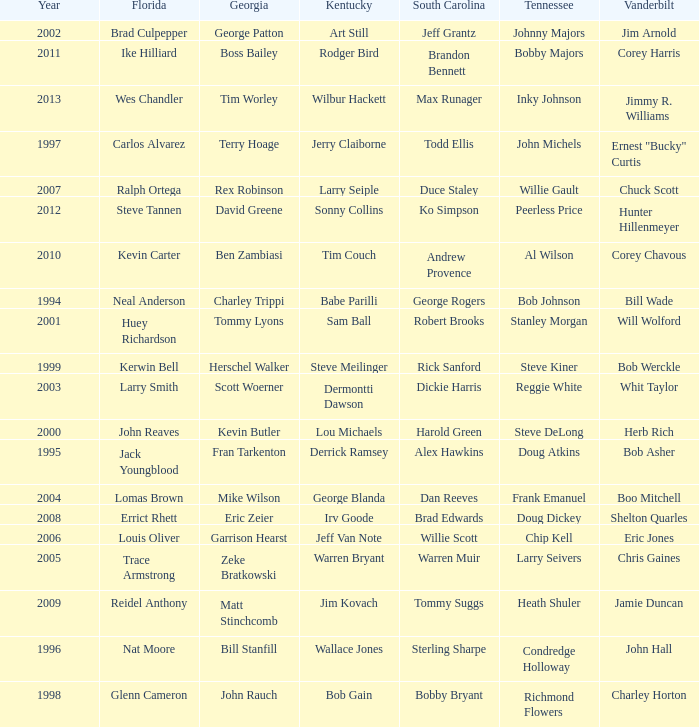What is the total Year of jeff van note ( Kentucky) 2006.0. 